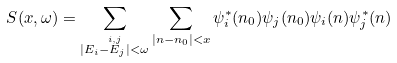<formula> <loc_0><loc_0><loc_500><loc_500>S ( x , \omega ) = \sum _ { \stackrel { i , j } { | E _ { i } - E _ { j } | < \omega } } \sum _ { | n - n _ { 0 } | < x } \psi _ { i } ^ { * } ( n _ { 0 } ) \psi _ { j } ( n _ { 0 } ) \psi _ { i } ( n ) \psi _ { j } ^ { * } ( n )</formula> 